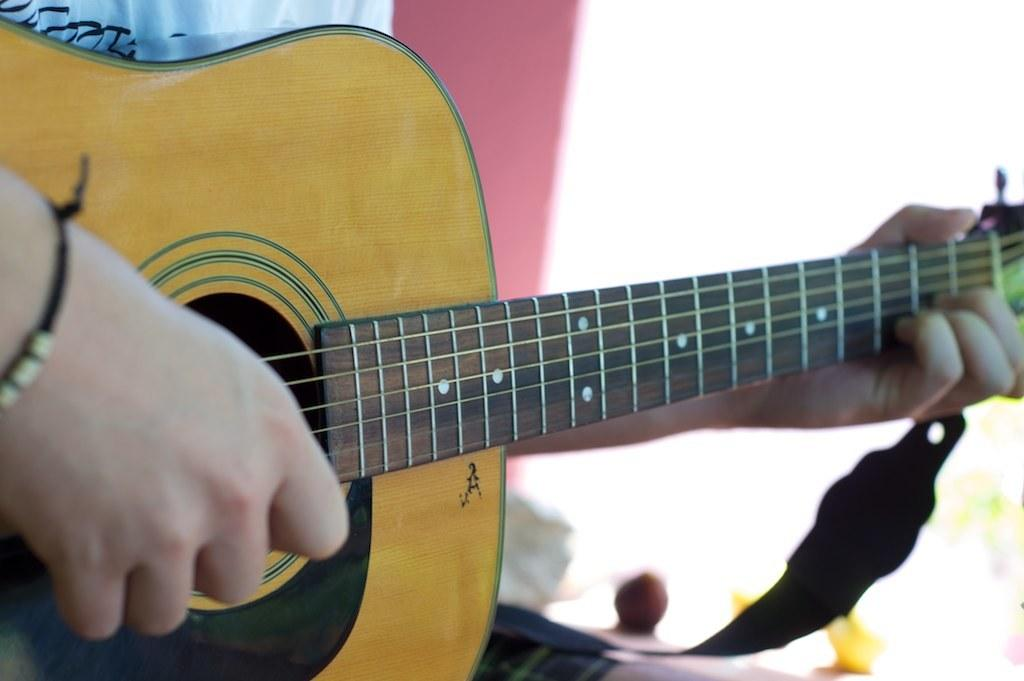What is the main subject of the image? The main subject of the image is a human hand. What is the human hand doing in the image? The human hand is playing a guitar in the image. How much wealth is represented by the vase in the image? There is no vase present in the image, so it is not possible to determine the wealth represented by a vase. 